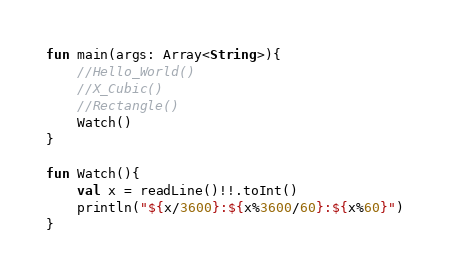<code> <loc_0><loc_0><loc_500><loc_500><_Kotlin_>fun main(args: Array<String>){
	//Hello_World()
	//X_Cubic()
	//Rectangle()
	Watch()
}

fun Watch(){
	val x = readLine()!!.toInt()
	println("${x/3600}:${x%3600/60}:${x%60}")
}
</code> 